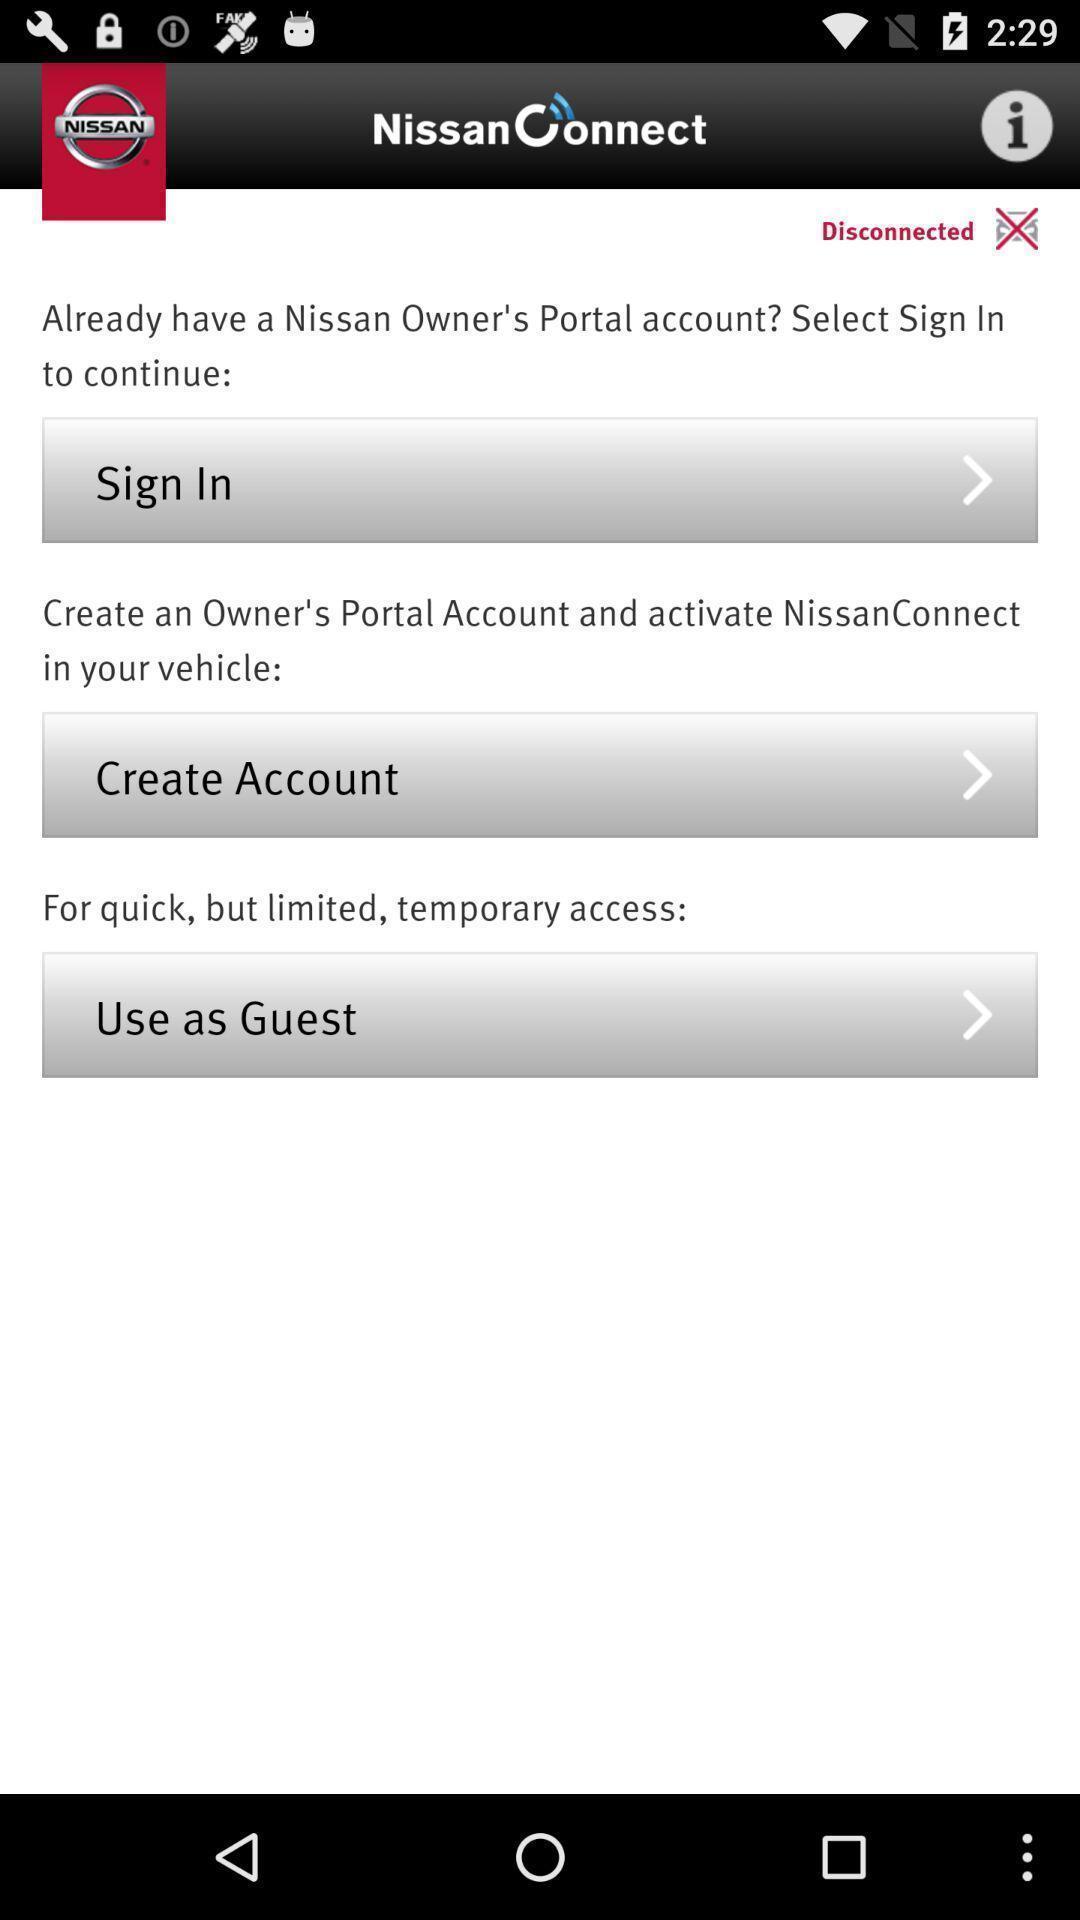Explain the elements present in this screenshot. Welcome page of a vehicle app. 